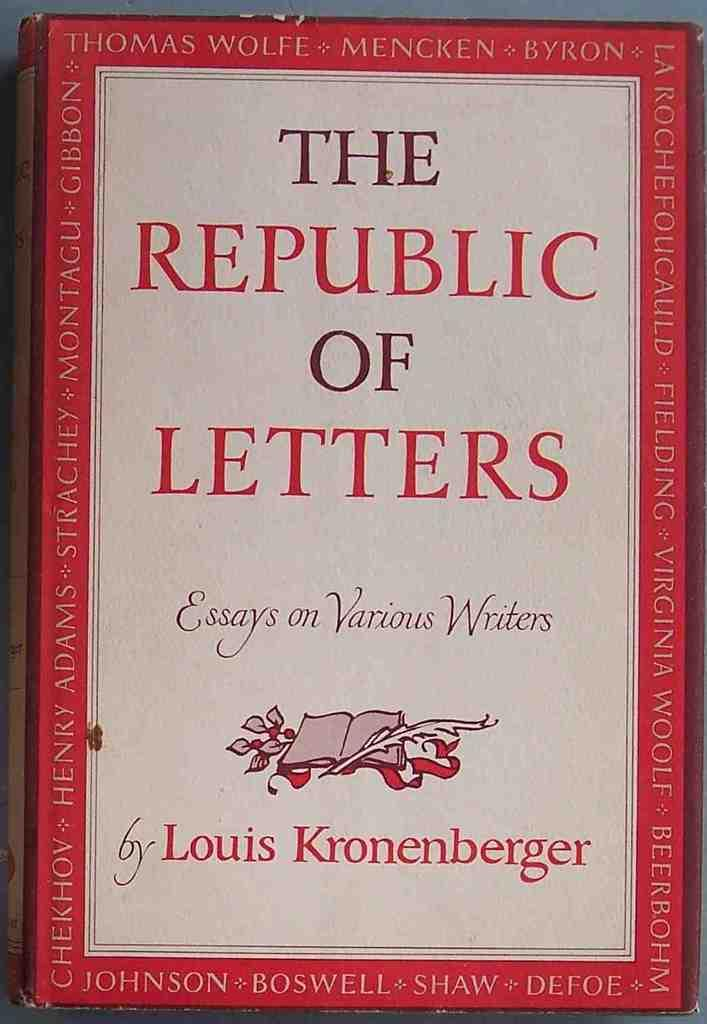Provide a one-sentence caption for the provided image. The Republic of Letters hardback book seems to be full of essays from various acclaimed writers from bygone eras. 